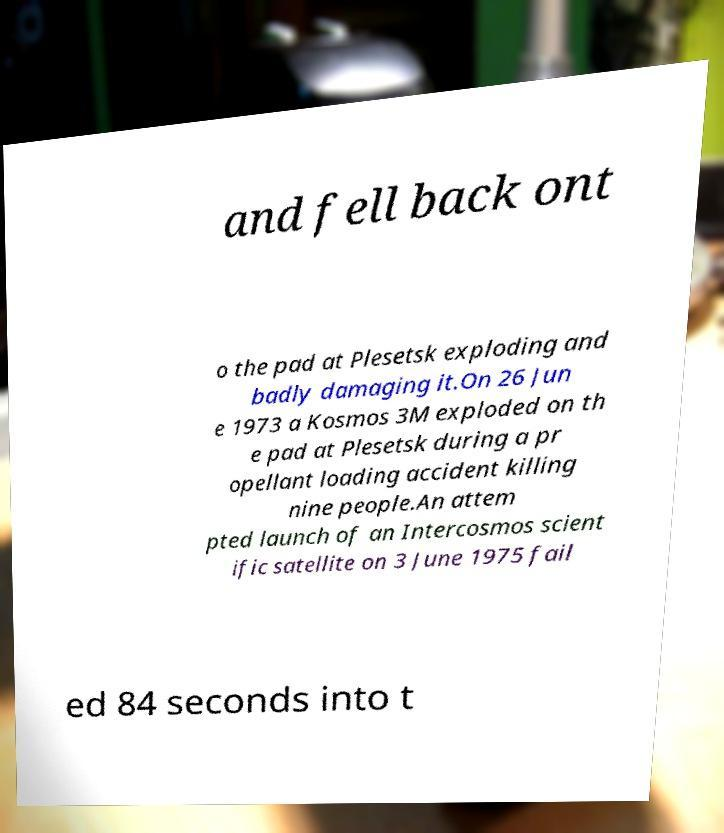I need the written content from this picture converted into text. Can you do that? and fell back ont o the pad at Plesetsk exploding and badly damaging it.On 26 Jun e 1973 a Kosmos 3M exploded on th e pad at Plesetsk during a pr opellant loading accident killing nine people.An attem pted launch of an Intercosmos scient ific satellite on 3 June 1975 fail ed 84 seconds into t 